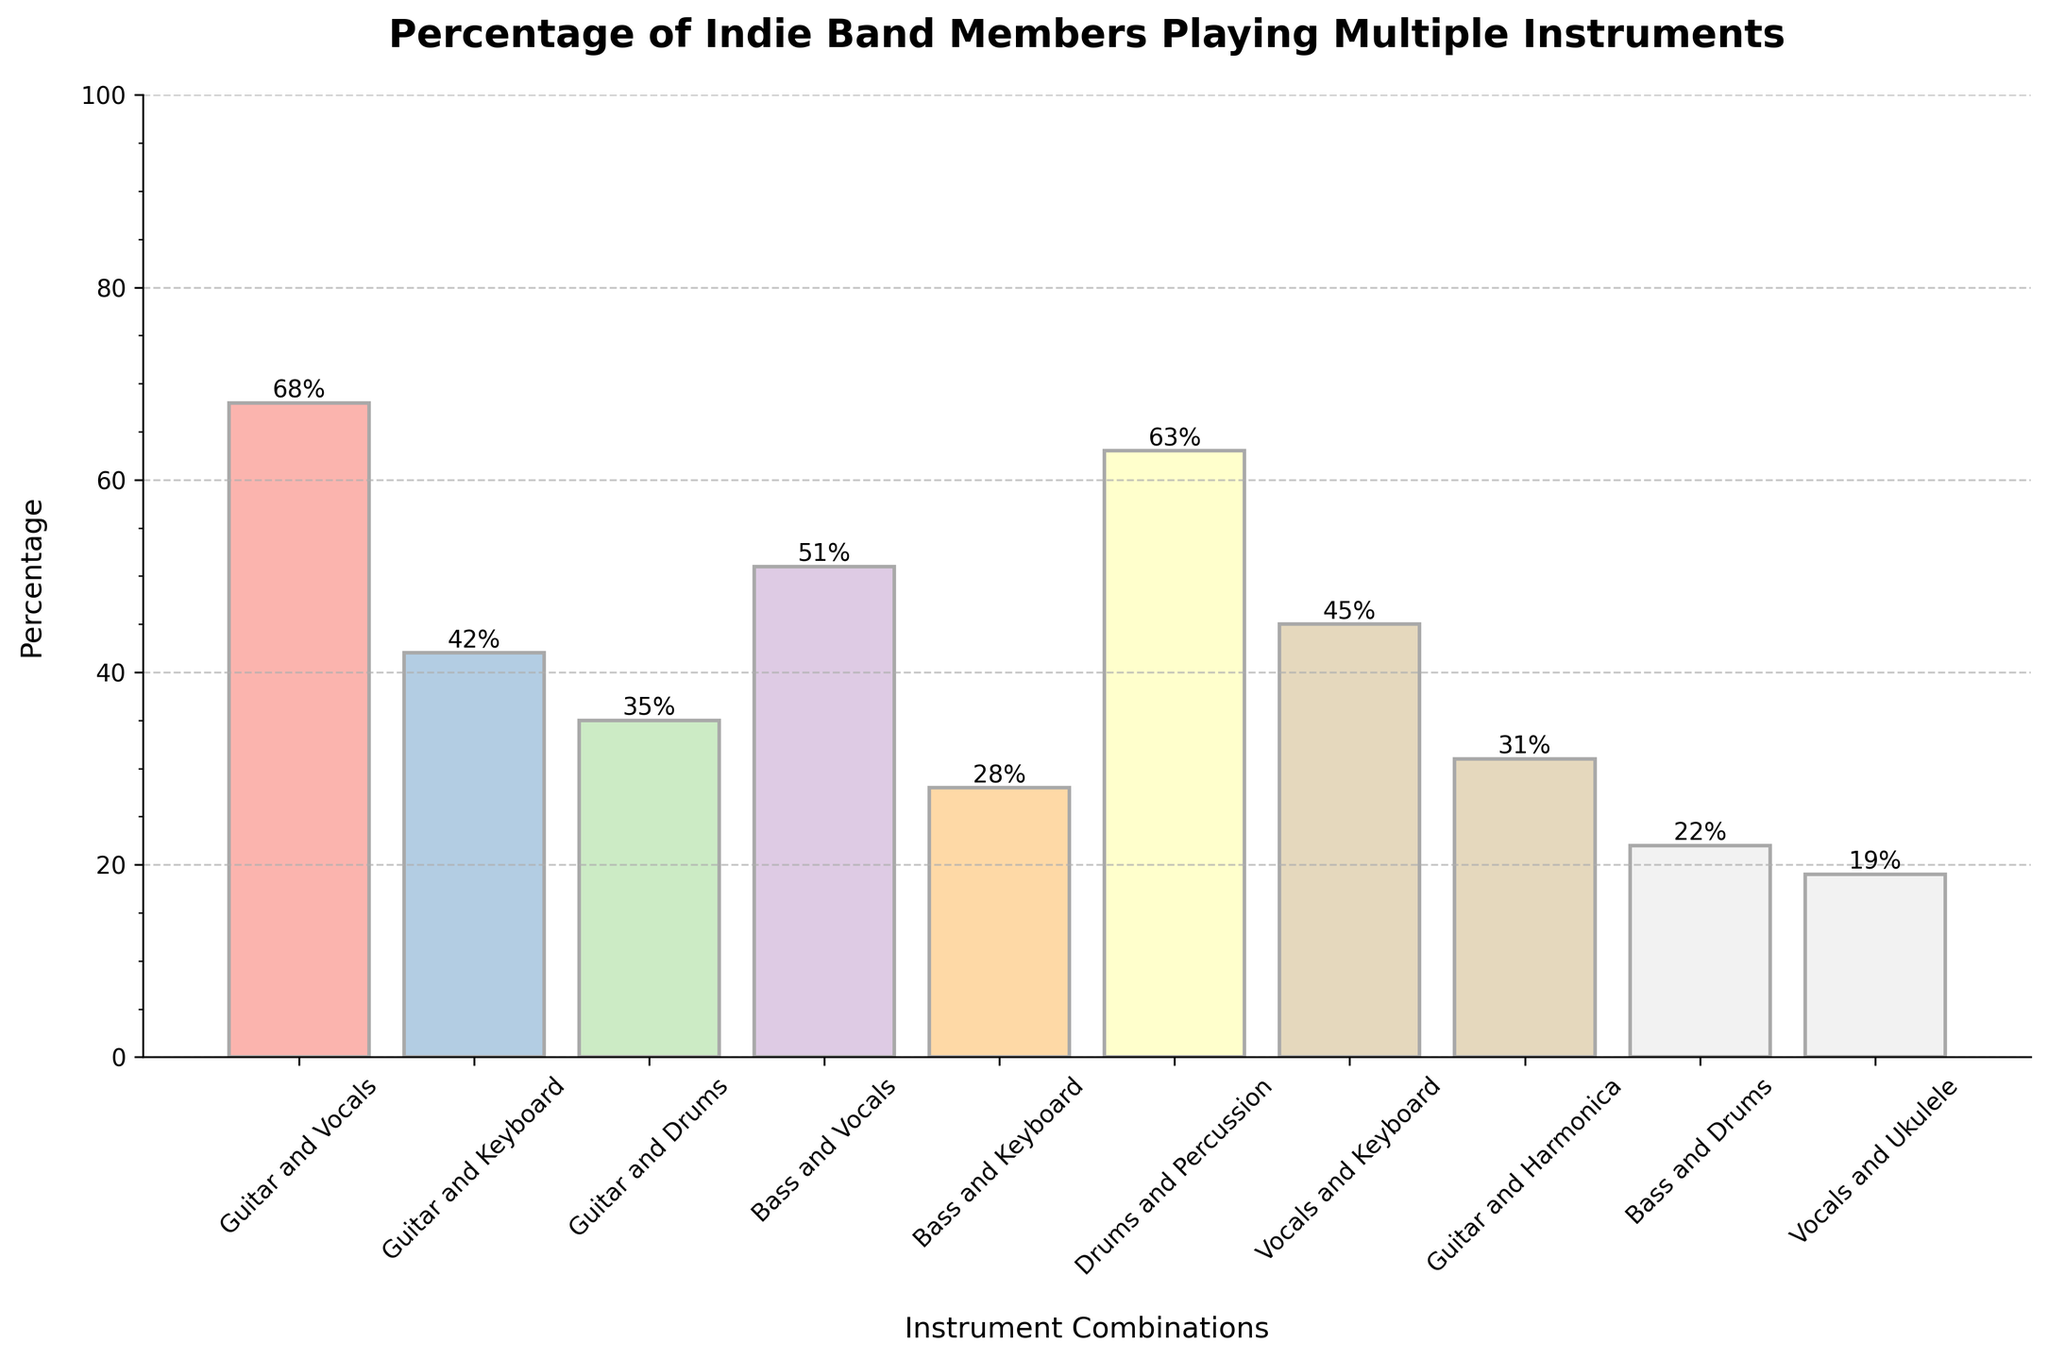What's the highest percentage of indie band members who play multiple instruments? The tallest bar in the chart represents the highest percentage. The combination of 'Guitar and Vocals' has the tallest bar, labeled with 68%.
Answer: 68% Which instrument combination has the lowest percentage of indie band members? The shortest bar in the chart represents the lowest percentage. The combination 'Vocals and Ukulele' has the shortest bar, labeled with 19%.
Answer: Vocals and Ukulele Is the percentage of members playing 'Bass and Drums' greater than that of 'Bass and Keyboard'? Refer to the bar heights for both combinations. 'Bass and Drums' has a percentage of 22%, while 'Bass and Keyboard' has 28%. Therefore, 22% is not greater than 28%.
Answer: No What's the difference in percentage between members who play 'Guitar and Drums' and 'Vocals and Keyboard'? Find the heights of relevant bars: 'Guitar and Drums' is 35% and 'Vocals and Keyboard' is 45%. The difference is 45% - 35% = 10%.
Answer: 10% What's the total percentage of members playing 'Guitar and Vocals', 'Drums and Percussion', and 'Bass and Vocals'? Sum the percentages of the respective combinations: 68% (Guitar and Vocals) + 63% (Drums and Percussion) + 51% (Bass and Vocals) = 182%.
Answer: 182% Which instrument combination has a percentage closest to the average of 'Guitar and Keyboard' and 'Guitar and Harmonica'? First find the average: (42% (Guitar and Keyboard) + 31% (Guitar and Harmonica))/2 = 36.5%. The combination closest to 36.5% is 'Guitar and Drums' at 35%.
Answer: Guitar and Drums Are there more members who play 'Vocals and Keyboard' or 'Guitar and Keyboard'? Compare the heights of both bars. 'Vocals and Keyboard' stands at 45%, whereas 'Guitar and Keyboard' stands at 42%. Thus, there are more members playing 'Vocals and Keyboard'.
Answer: Vocals and Keyboard What's the combined percentage for all instrument combinations that include 'Guitar'? Combine the percentages of all relevant combinations: 68% (Guitar and Vocals) + 42% (Guitar and Keyboard) + 35% (Guitar and Drums) + 31% (Guitar and Harmonica) = 176%.
Answer: 176% 